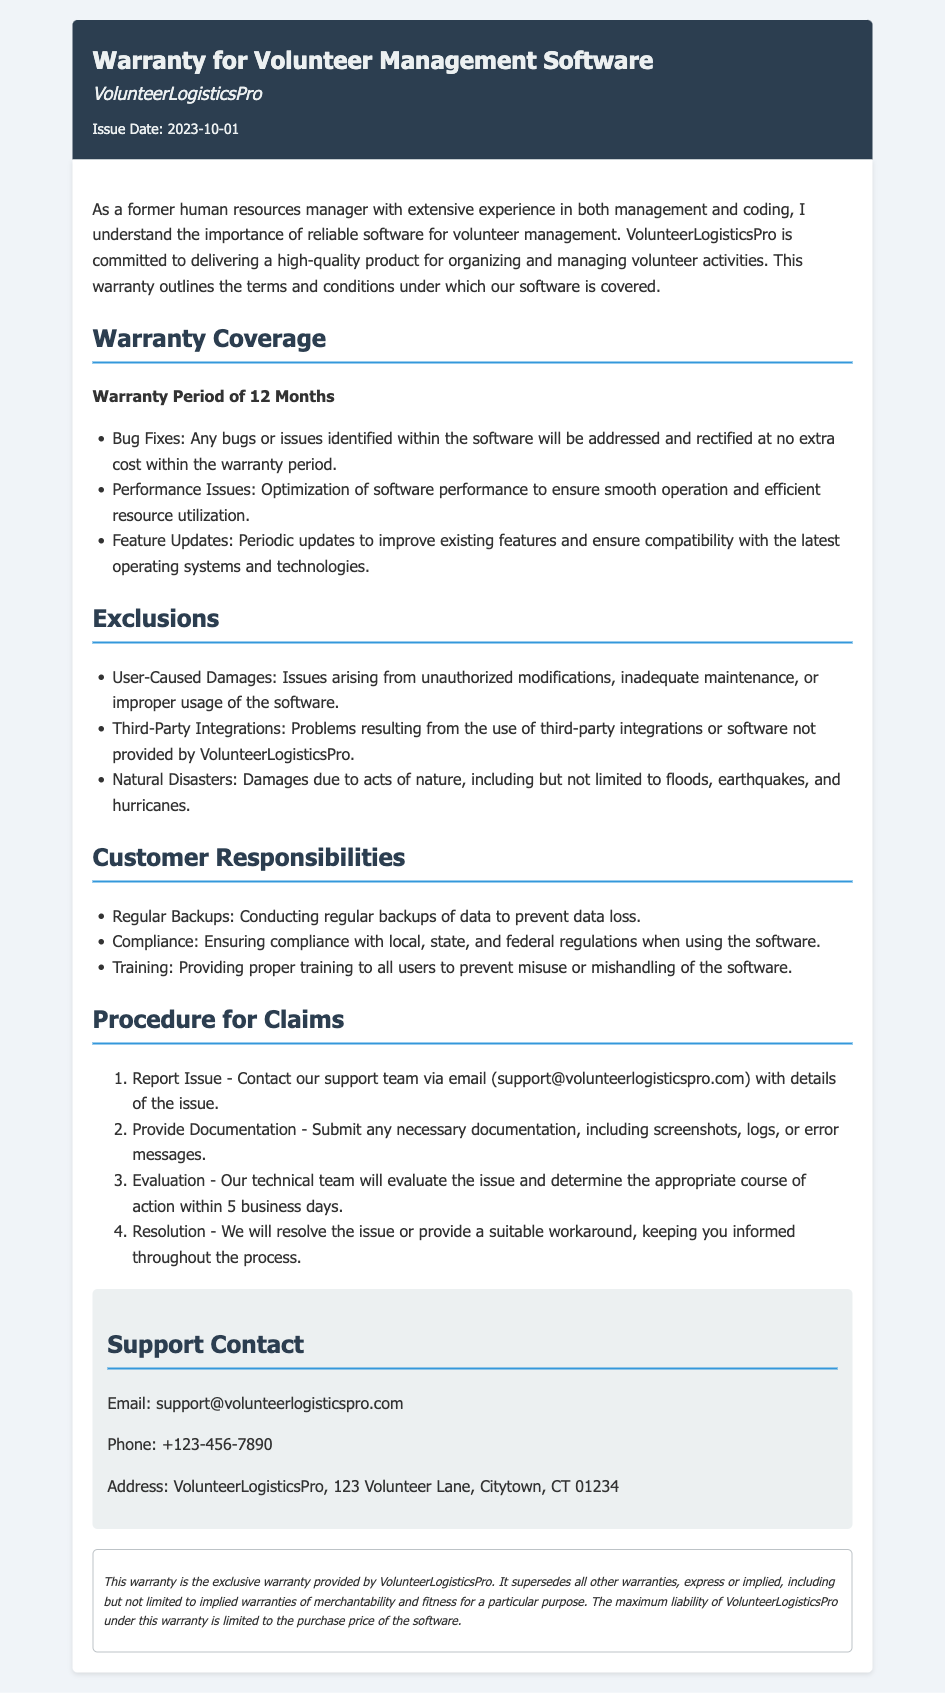what is the warranty period for the software? The warranty period outlined in the document is clearly stated as 12 months.
Answer: 12 Months who is the organization providing the warranty? The name of the organization mentioned in the document is VolunteerLogisticsPro.
Answer: VolunteerLogisticsPro what is excluded from the warranty coverage? The document lists several exclusions, one of which is user-caused damages.
Answer: User-Caused Damages what should customers conduct to prevent data loss? The warranty specifies that customers are responsible for conducting regular backups of data.
Answer: Regular Backups what is the email contact for support? The document provides a specific email for support inquiries, which is support@volunteerlogisticspro.com.
Answer: support@volunteerlogisticspro.com how long does the evaluation of a reported issue take? According to the document, the technical team will evaluate the issue within 5 business days.
Answer: 5 business days what type of damages are excluded due to natural disasters? The exclusions include damages that occur because of natural disasters, such as floods.
Answer: Natural Disasters what should customers do before reporting an issue? Customers must provide documentation, such as screenshots or error messages, as part of the claims process.
Answer: Provide Documentation 